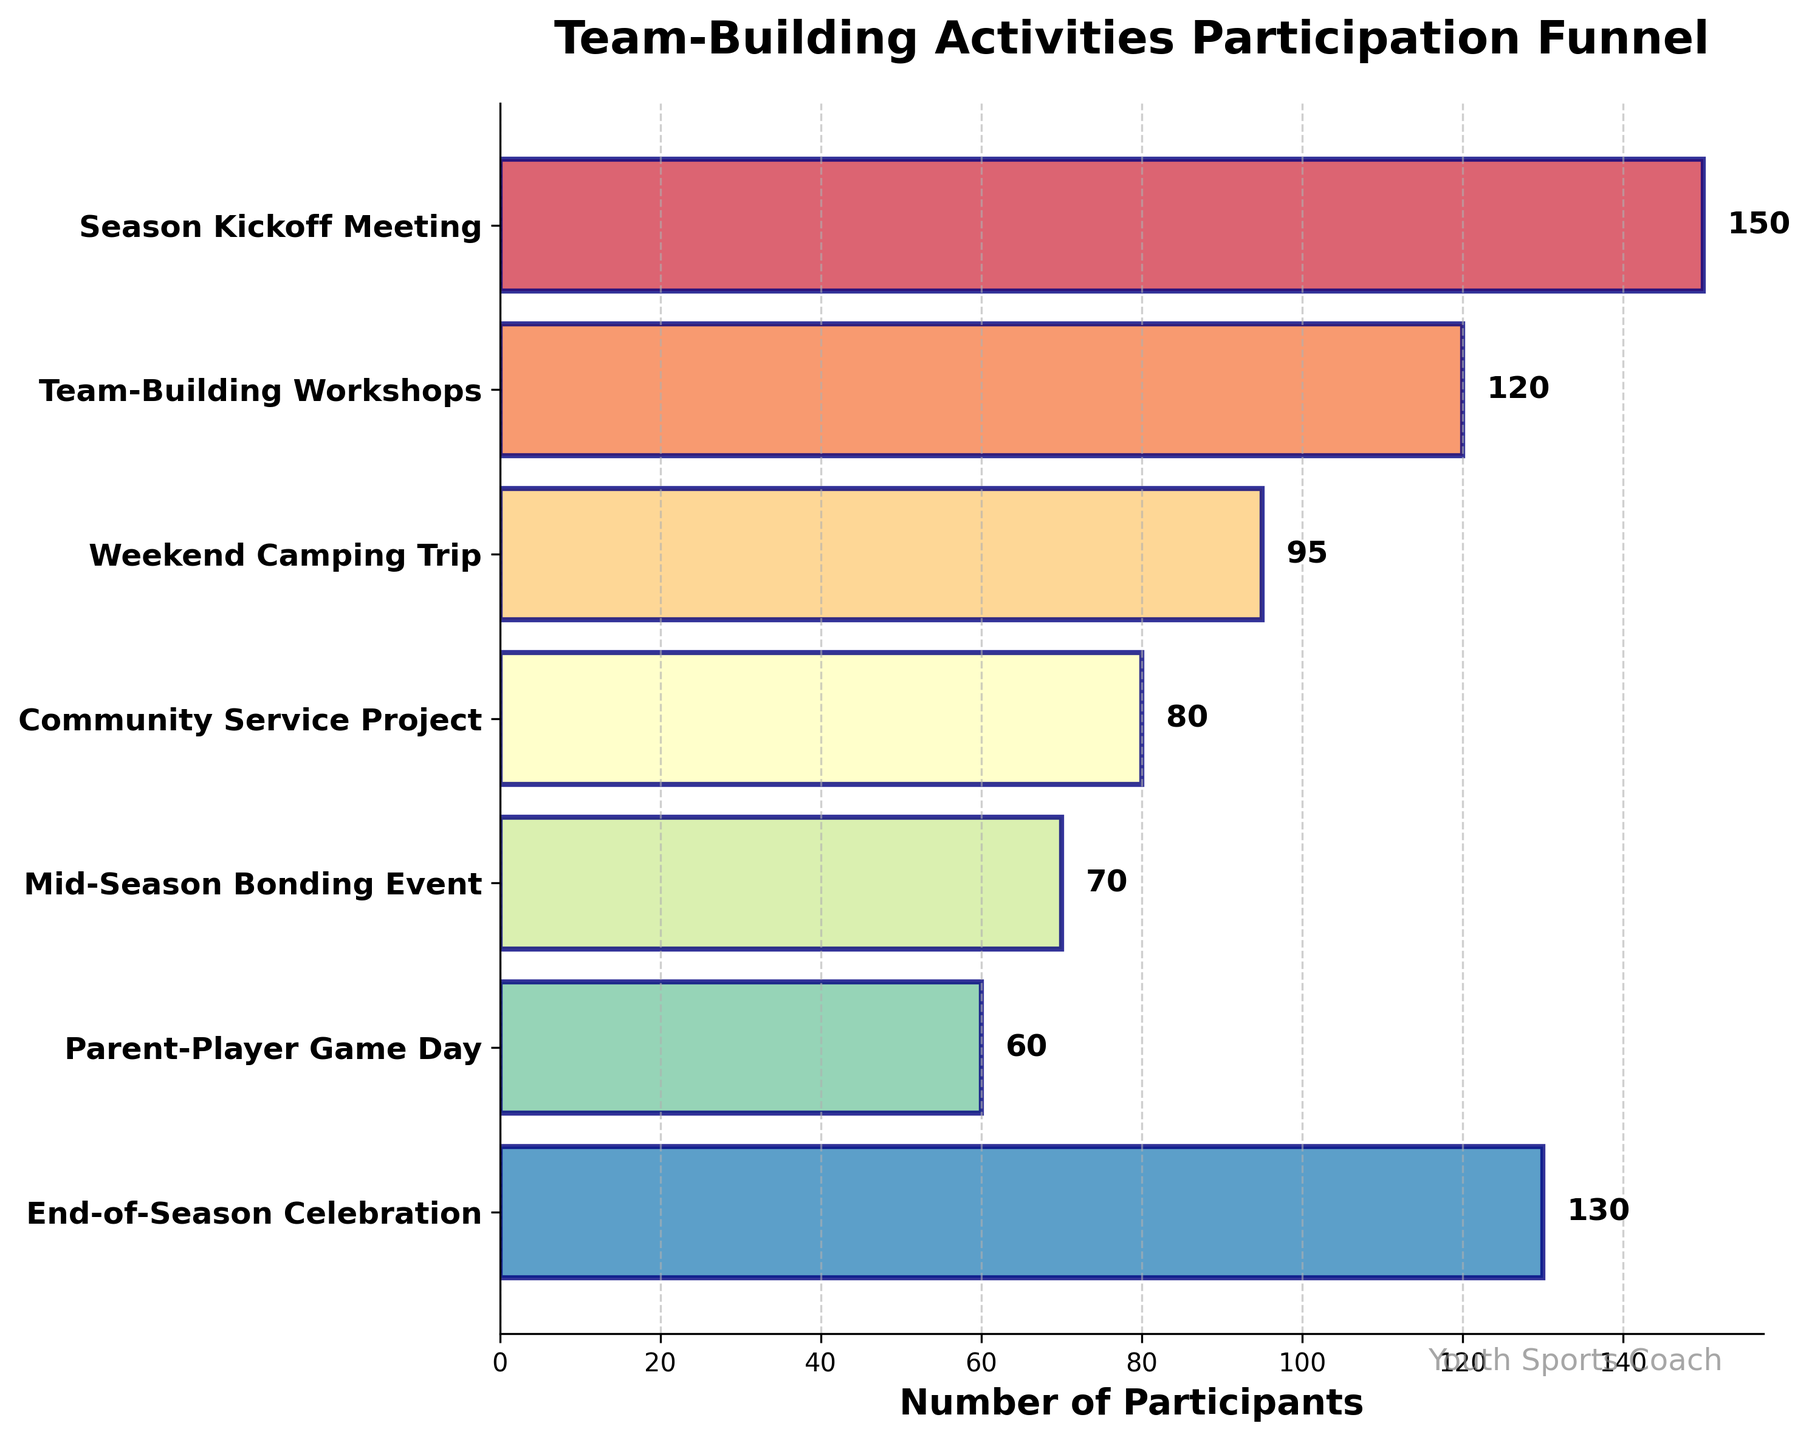What is the title of the figure? The title of the figure is displayed at the top. It provides context for the data being presented. The title reads "Team-Building Activities Participation Funnel."
Answer: Team-Building Activities Participation Funnel How many activities are displayed in the figure? By counting the horizontal bars or the y-axis labels, we can see there are seven activities listed.
Answer: Seven Which team-building activity had the highest participation? The bar with the maximum width represents the activity with the highest participation. The first bar from the top, labeled "Season Kickoff Meeting," is the longest.
Answer: Season Kickoff Meeting What is the participation difference between the Weekend Camping Trip and Parent-Player Game Day? From the figure, the width of the bars shows participants. Weekend Camping Trip has 95 participants, and Parent-Player Game Day has 60. Subtracting these gives us 95 - 60 = 35.
Answer: 35 What is the average number of participants across all activities? Summing the participants for all activities (150 + 120 + 95 + 80 + 70 + 60 + 130 = 705) and dividing by the number of activities (7) gives the average, 705 / 7 = 100.71.
Answer: 100.71 Which activity had fewer participants than the Mid-Season Bonding Event but more than the Parent-Player Game Day? From the figure, Mid-Season Bonding Event had 70 participants and Parent-Player Game Day had 60. The activity with participants between these is "Community Service Project" with 80 participants.
Answer: Community Service Project How much more participation did the End-of-Season Celebration have compared to the Mid-Season Bonding Event? By looking at the figure, the End-of-Season Celebration had 130 participants, and the Mid-Season Bonding Event had 70. The difference is 130 - 70 = 60.
Answer: 60 Sort the activities from the least to the most participants. The list of activities and their participant numbers needs sorting in ascending order: Parent-Player Game Day (60), Mid-Season Bonding Event (70), Community Service Project (80), Weekend Camping Trip (95), Team-Building Workshops (120), End-of-Season Celebration (130), and Season Kickoff Meeting (150).
Answer: Parent-Player Game Day, Mid-Season Bonding Event, Community Service Project, Weekend Camping Trip, Team-Building Workshops, End-of-Season Celebration, Season Kickoff Meeting Approximately what percentage of participants attended the Team-Building Workshops compared to the total number of participants across all activities? First, sum total participants (705). For Team-Building Workshops: (120/705) * 100 ≈ 17.02%.
Answer: 17.02% Do more participants attend the Parent-Player Game Day or the Mid-Season Bonding Event? By examining the figure, the bar for the Mid-Season Bonding Event is longer, representing 70 participants compared to 60 for Parent-Player Game Day.
Answer: Mid-Season Bonding Event 